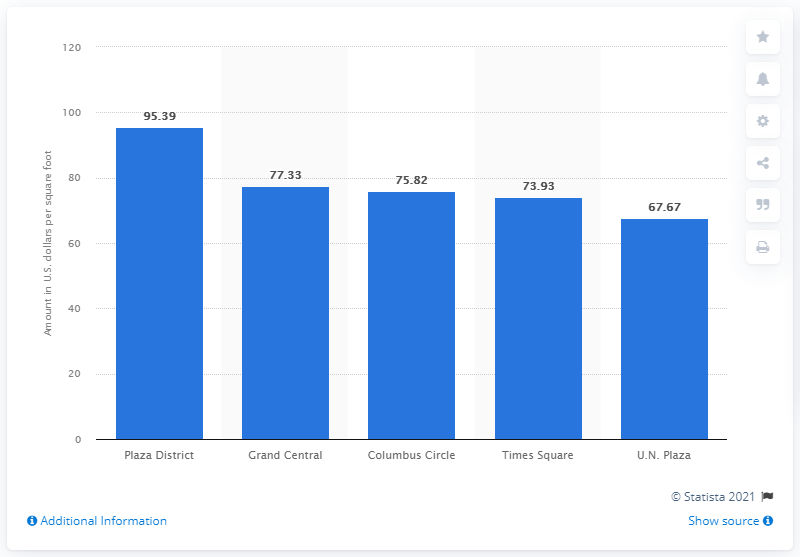Indicate a few pertinent items in this graphic. The asking rent in the Plaza District was approximately $95.39 per square foot. 